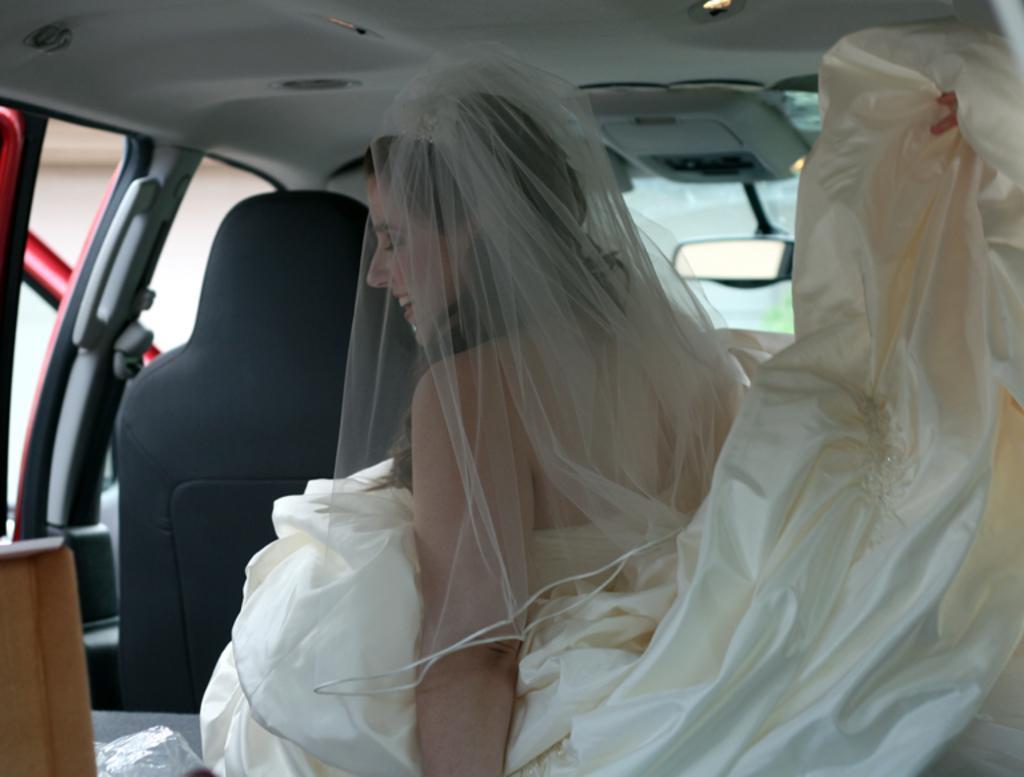Could you give a brief overview of what you see in this image? In the image we can see there is woman who is sitting in the car and she is wearing a wedding gown and on the head there is a netted cloth and she is smiling. 